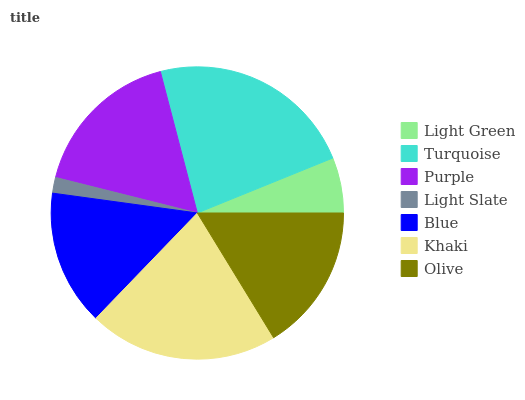Is Light Slate the minimum?
Answer yes or no. Yes. Is Turquoise the maximum?
Answer yes or no. Yes. Is Purple the minimum?
Answer yes or no. No. Is Purple the maximum?
Answer yes or no. No. Is Turquoise greater than Purple?
Answer yes or no. Yes. Is Purple less than Turquoise?
Answer yes or no. Yes. Is Purple greater than Turquoise?
Answer yes or no. No. Is Turquoise less than Purple?
Answer yes or no. No. Is Olive the high median?
Answer yes or no. Yes. Is Olive the low median?
Answer yes or no. Yes. Is Light Slate the high median?
Answer yes or no. No. Is Blue the low median?
Answer yes or no. No. 